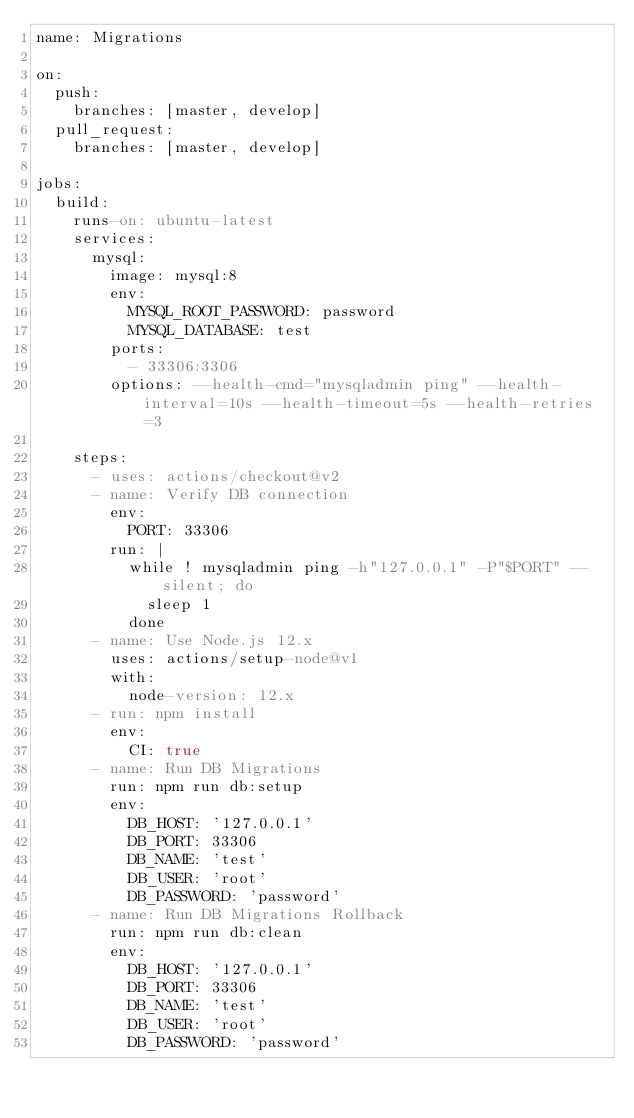<code> <loc_0><loc_0><loc_500><loc_500><_YAML_>name: Migrations

on:
  push:
    branches: [master, develop]
  pull_request:
    branches: [master, develop]

jobs:
  build:
    runs-on: ubuntu-latest
    services:
      mysql:
        image: mysql:8
        env:
          MYSQL_ROOT_PASSWORD: password
          MYSQL_DATABASE: test
        ports:
          - 33306:3306
        options: --health-cmd="mysqladmin ping" --health-interval=10s --health-timeout=5s --health-retries=3

    steps:
      - uses: actions/checkout@v2
      - name: Verify DB connection
        env:
          PORT: 33306
        run: |
          while ! mysqladmin ping -h"127.0.0.1" -P"$PORT" --silent; do
            sleep 1
          done
      - name: Use Node.js 12.x
        uses: actions/setup-node@v1
        with:
          node-version: 12.x
      - run: npm install
        env:
          CI: true
      - name: Run DB Migrations
        run: npm run db:setup
        env:
          DB_HOST: '127.0.0.1'
          DB_PORT: 33306
          DB_NAME: 'test'
          DB_USER: 'root'
          DB_PASSWORD: 'password'
      - name: Run DB Migrations Rollback
        run: npm run db:clean
        env:
          DB_HOST: '127.0.0.1'
          DB_PORT: 33306
          DB_NAME: 'test'
          DB_USER: 'root'
          DB_PASSWORD: 'password'
</code> 